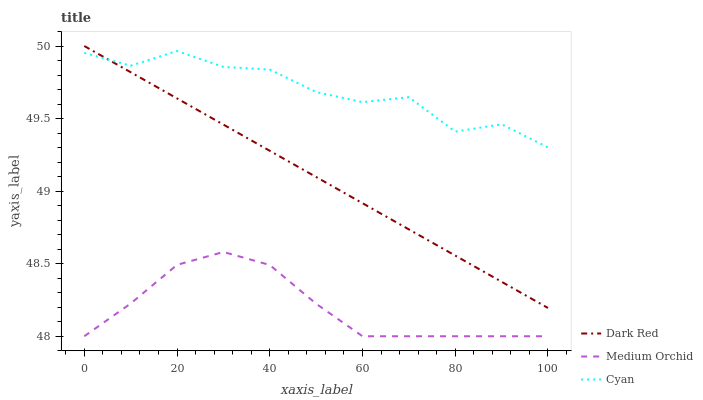Does Cyan have the minimum area under the curve?
Answer yes or no. No. Does Medium Orchid have the maximum area under the curve?
Answer yes or no. No. Is Medium Orchid the smoothest?
Answer yes or no. No. Is Medium Orchid the roughest?
Answer yes or no. No. Does Cyan have the lowest value?
Answer yes or no. No. Does Cyan have the highest value?
Answer yes or no. No. Is Medium Orchid less than Cyan?
Answer yes or no. Yes. Is Dark Red greater than Medium Orchid?
Answer yes or no. Yes. Does Medium Orchid intersect Cyan?
Answer yes or no. No. 